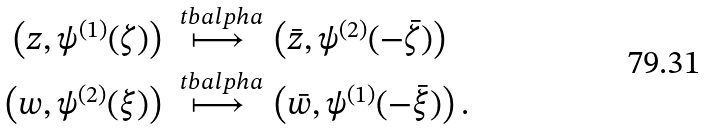Convert formula to latex. <formula><loc_0><loc_0><loc_500><loc_500>\left ( z , \psi ^ { ( 1 ) } ( \zeta ) \right ) & \stackrel { \ t b a l p h a } \longmapsto \left ( \bar { z } , \psi ^ { ( 2 ) } ( - \bar { \zeta } ) \right ) \\ \left ( w , \psi ^ { ( 2 ) } ( \xi ) \right ) & \stackrel { \ t b a l p h a } \longmapsto \left ( \bar { w } , \psi ^ { ( 1 ) } ( - \bar { \xi } ) \right ) .</formula> 